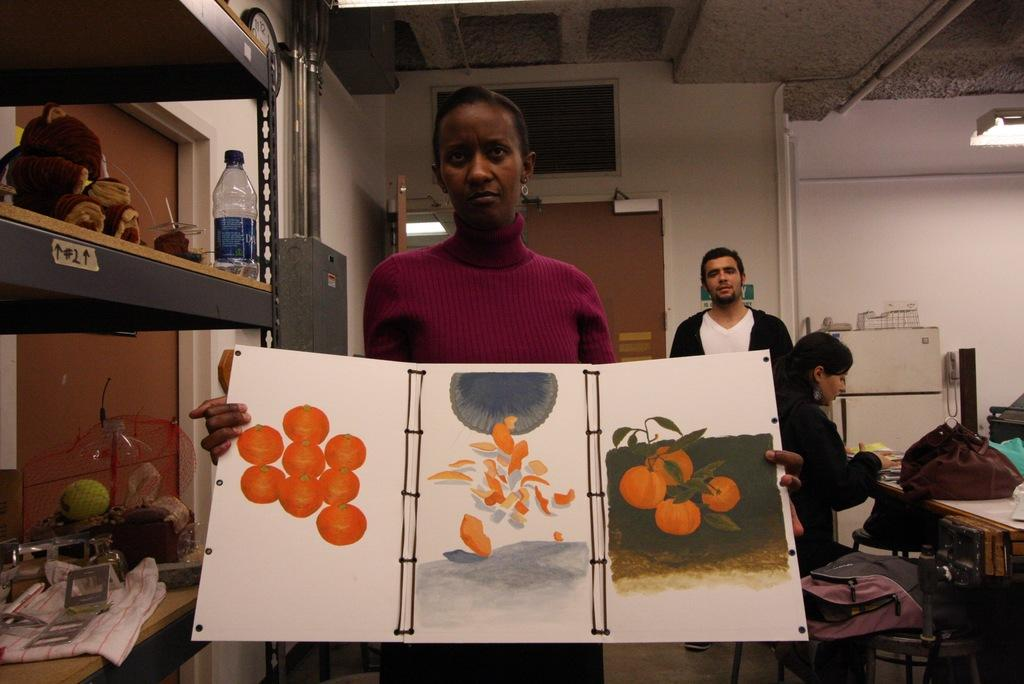Who is the main subject in the image? There is a woman in the image. What is the woman holding in the image? The woman is holding a chart. What can be seen in the background of the image? There are racks in the image. How many people are present in the image? There are two persons at the back side of the image. What object is on the table in the image? There is a bag on the table in the image. What time is displayed on the clock in the image? There is no clock present in the image, so the time cannot be determined. What type of notebook is the woman using to take notes in the image? There is no notebook visible in the image; the woman is holding a chart. 